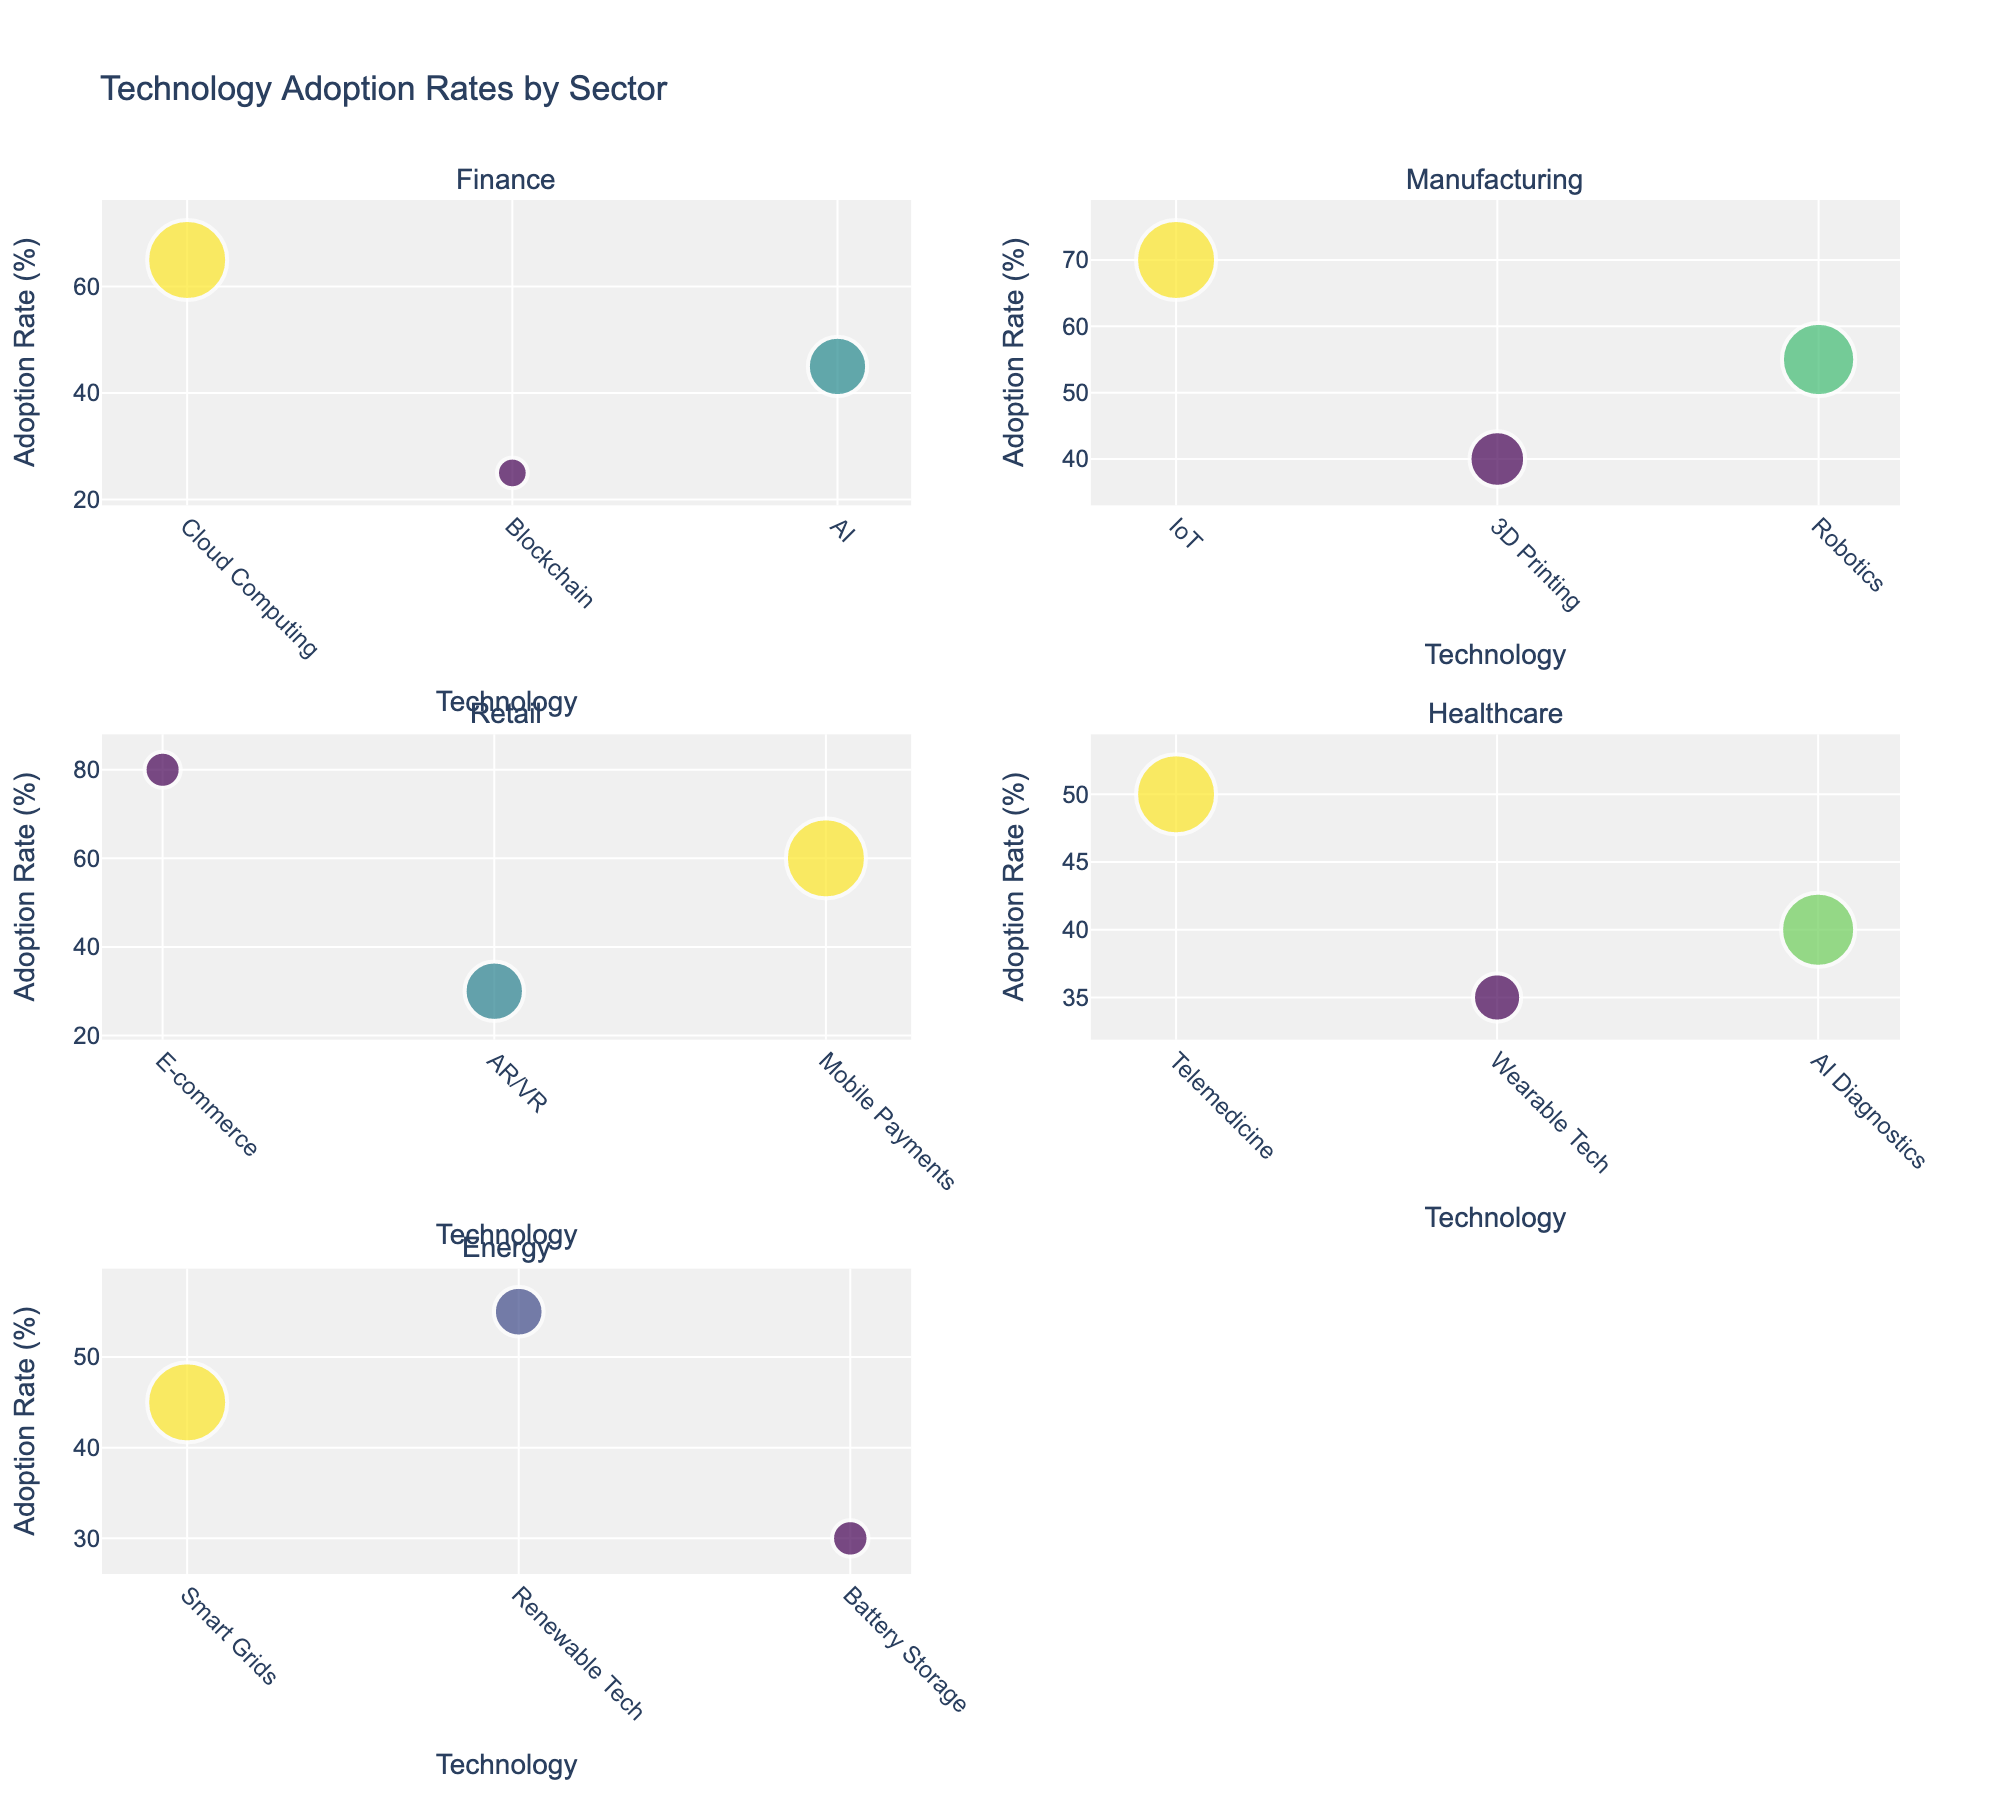Which sector shows the highest adoption rate for a technology? Look for the bubble highest on the adoption rate (Y-axis). In the Retail sector, E-commerce has an adoption rate of 80%.
Answer: Retail What is the adoption rate for Cloud Computing in the Finance sector? Locate the bubble labeled Cloud Computing under the Finance subplot. The Y-value shows the adoption rate.
Answer: 65% Which technology in the Healthcare sector is associated with the oldest company? Compare the sizes of the bubbles in the Healthcare sector. The largest bubble represents the oldest company. The largest bubble is Telemedicine.
Answer: Telemedicine How does the adoption rate of AI in Healthcare compare to AI in Finance? Compare the Y-values (adoption rates) of the AI bubbles in both sectors. AI in Finance has a higher adoption rate of 45%, compared to AI Diagnostics in Healthcare which is 40%.
Answer: Higher in Finance Which sector has the oldest company overall? Look for the largest bubble on the subplots, which indicates the oldest company age. The largest bubble is in the Finance sector for Mobile Payments with a company age of 118.
Answer: Finance What is the adoption rate of batteries storage technology in the Energy sector? Locate the bubble labeled Battery Storage in the Energy subplot. The Y-value shows its adoption rate.
Answer: 30% How many technologies in the Retail sector have an adoption rate above 50%? Count the bubbles in the Retail sector subplot with Y-values above 50. There are two: E-commerce and Mobile Payments.
Answer: 2 Which technology in the Finance sector involves the youngest company? Compare the sizes of the bubbles in the Finance sector. The smallest bubble represents the youngest company. The smallest bubble is Blockchain.
Answer: Blockchain Is the adoption of IoT technology higher in Manufacturing or Telemedicine in Healthcare? Compare the Y-values (adoption rates) of the IoT bubble in Manufacturing and the Telemedicine bubble in Healthcare. IoT has an adoption rate of 70% and Telemedicine has 50%.
Answer: Higher in Manufacturing 